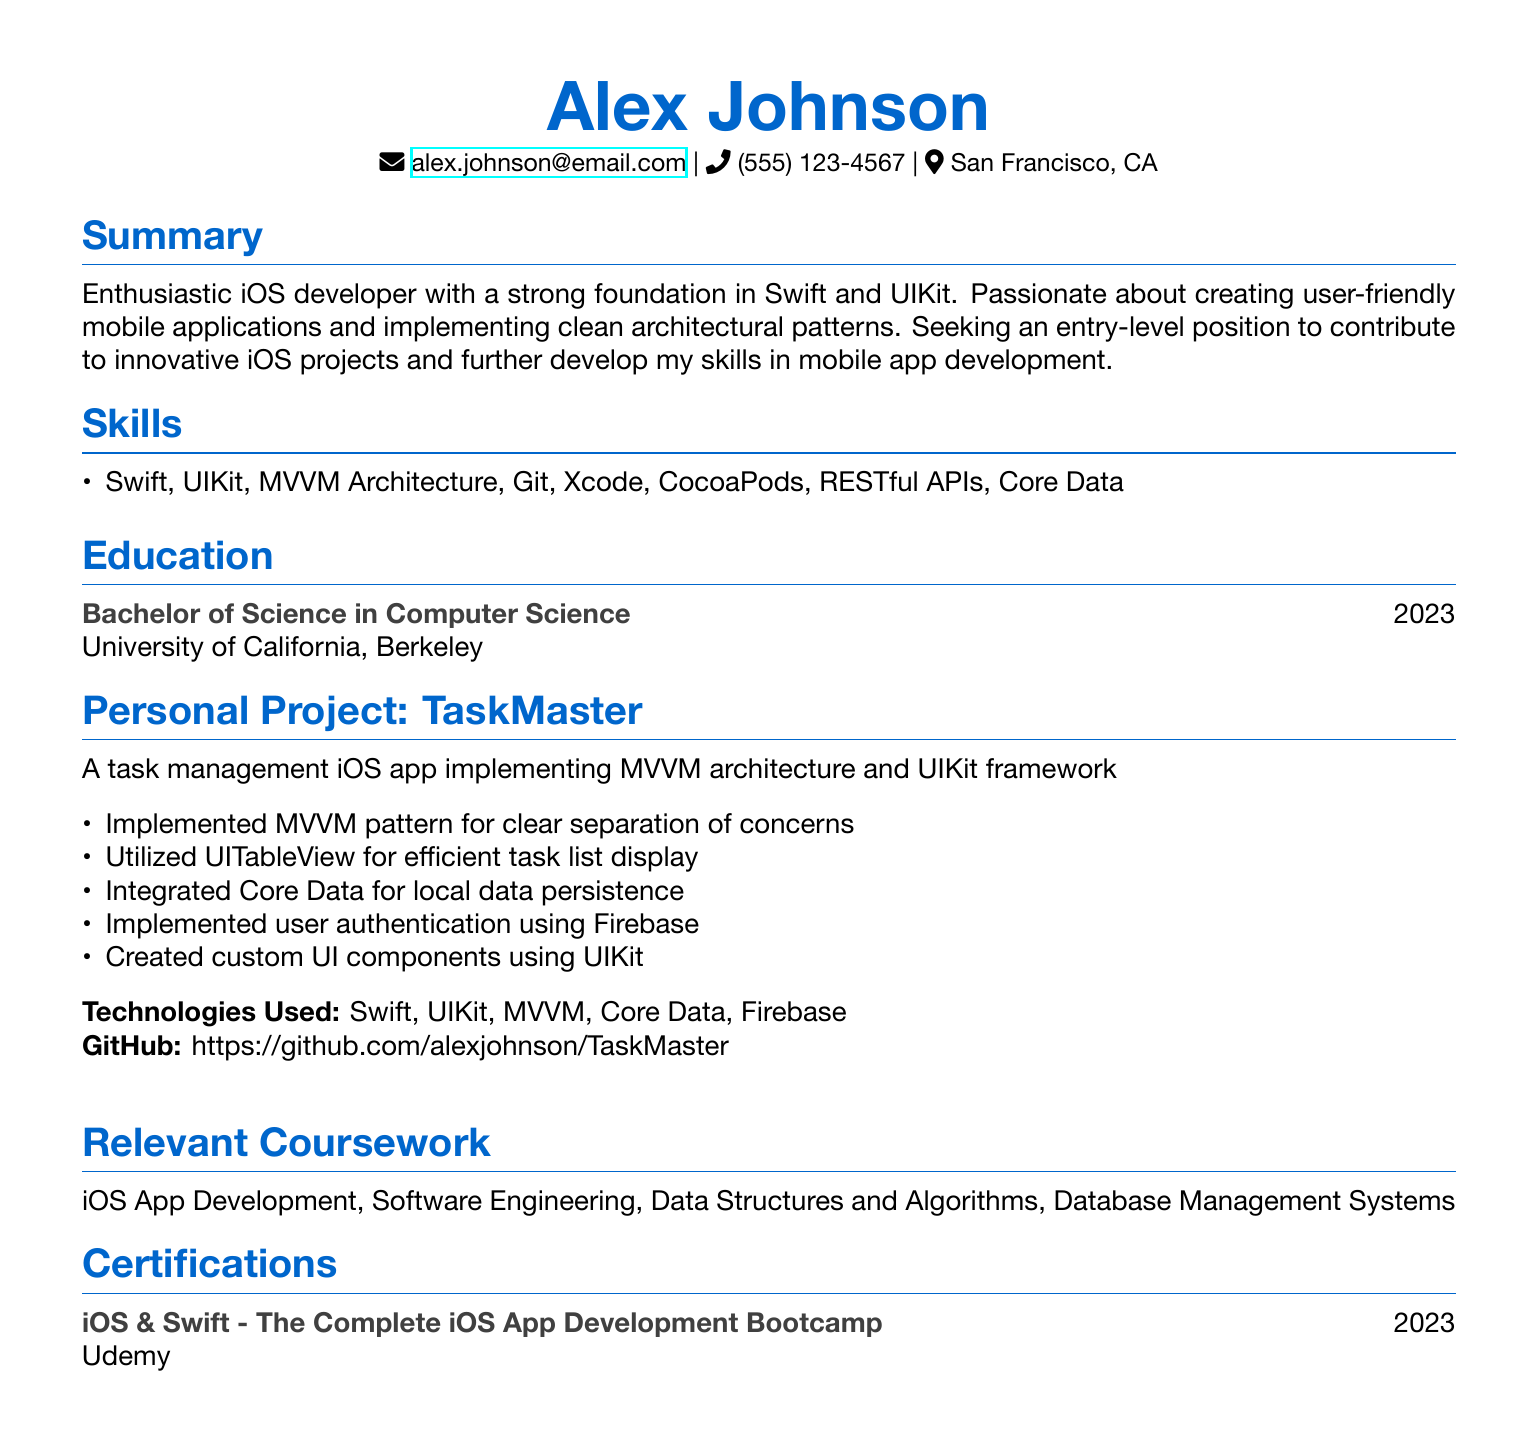What is the name of the individual? The individual's name is listed prominently at the top of the document.
Answer: Alex Johnson What year did Alex graduate? The graduation year is provided in the education section of the document.
Answer: 2023 What framework did Alex use in the personal project? The personal project section specifies the framework used for development.
Answer: UIKit Which architecture pattern was implemented in the personal project? The details of the personal project explicitly mention the architecture pattern used.
Answer: MVVM How many certifications does Alex have? The certifications section lists the number of certifications.
Answer: 1 What is the GitHub link to the personal project? The personal project section includes a GitHub link for reference.
Answer: https://github.com/alexjohnson/TaskMaster What is one of Alex's skills? The skills section lists various skills, any of which could be an answer.
Answer: Swift Which university did Alex attend? The education section states the institution from which Alex obtained their degree.
Answer: University of California, Berkeley What is the main purpose of this document? This document is structured to present qualifications for a job application.
Answer: Resume 